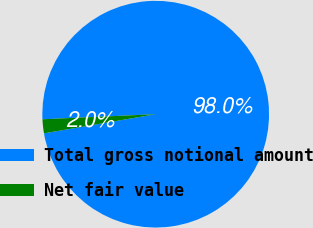Convert chart to OTSL. <chart><loc_0><loc_0><loc_500><loc_500><pie_chart><fcel>Total gross notional amount<fcel>Net fair value<nl><fcel>98.01%<fcel>1.99%<nl></chart> 